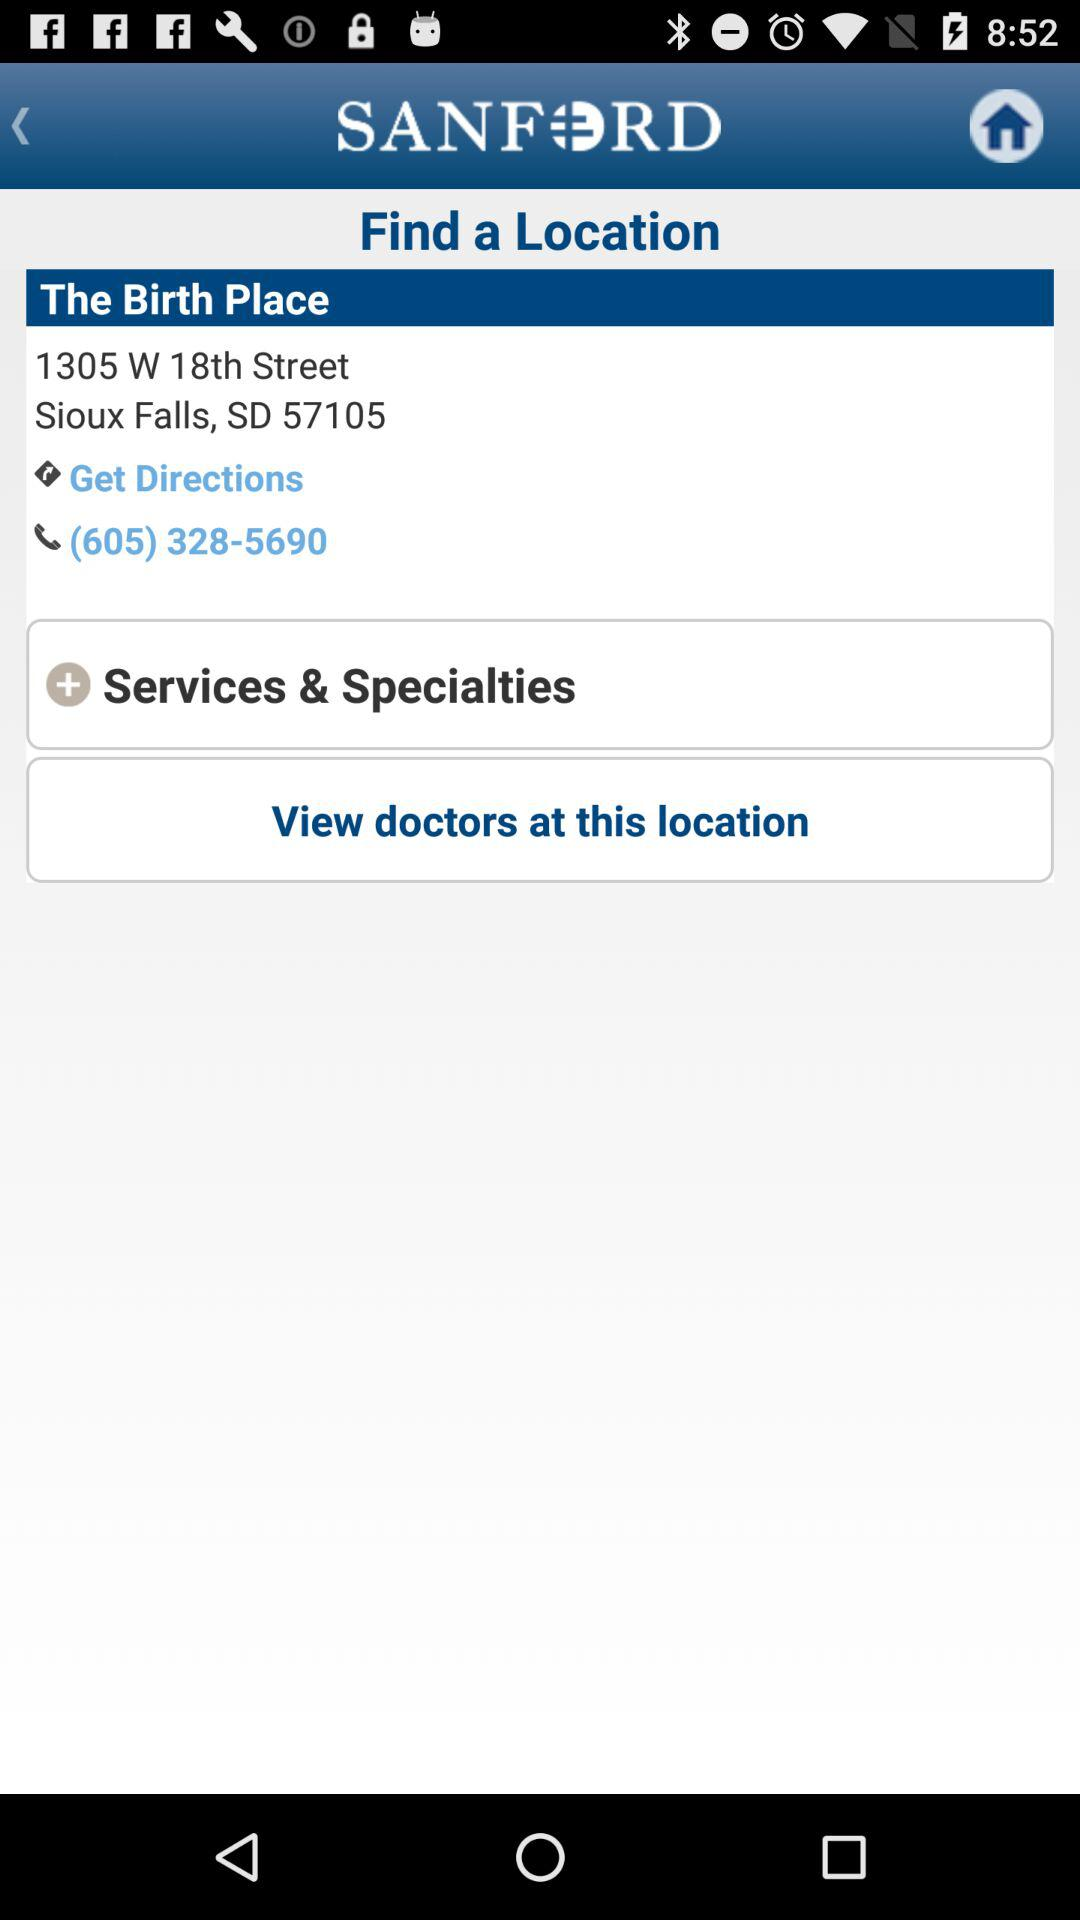What is the location? The location is 1305 W 18th Street, Sioux Falls, SD 57105. 